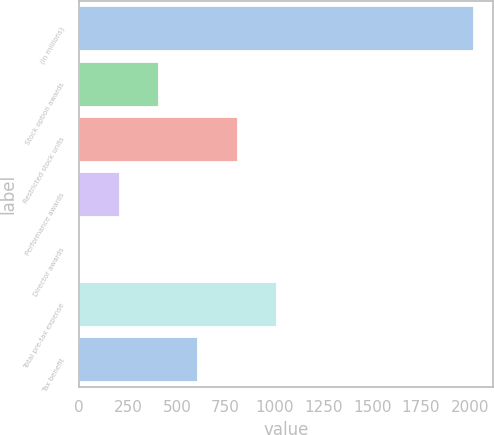Convert chart to OTSL. <chart><loc_0><loc_0><loc_500><loc_500><bar_chart><fcel>(In millions)<fcel>Stock option awards<fcel>Restricted stock units<fcel>Performance awards<fcel>Director awards<fcel>Total pre-tax expense<fcel>Tax benefit<nl><fcel>2015<fcel>403.72<fcel>806.54<fcel>202.31<fcel>0.9<fcel>1007.95<fcel>605.13<nl></chart> 